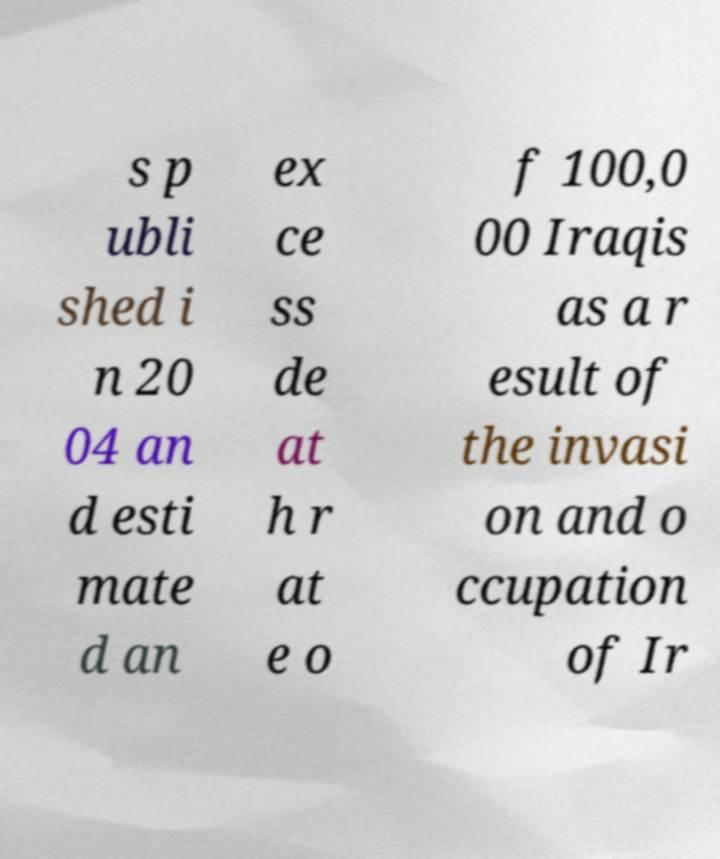I need the written content from this picture converted into text. Can you do that? s p ubli shed i n 20 04 an d esti mate d an ex ce ss de at h r at e o f 100,0 00 Iraqis as a r esult of the invasi on and o ccupation of Ir 